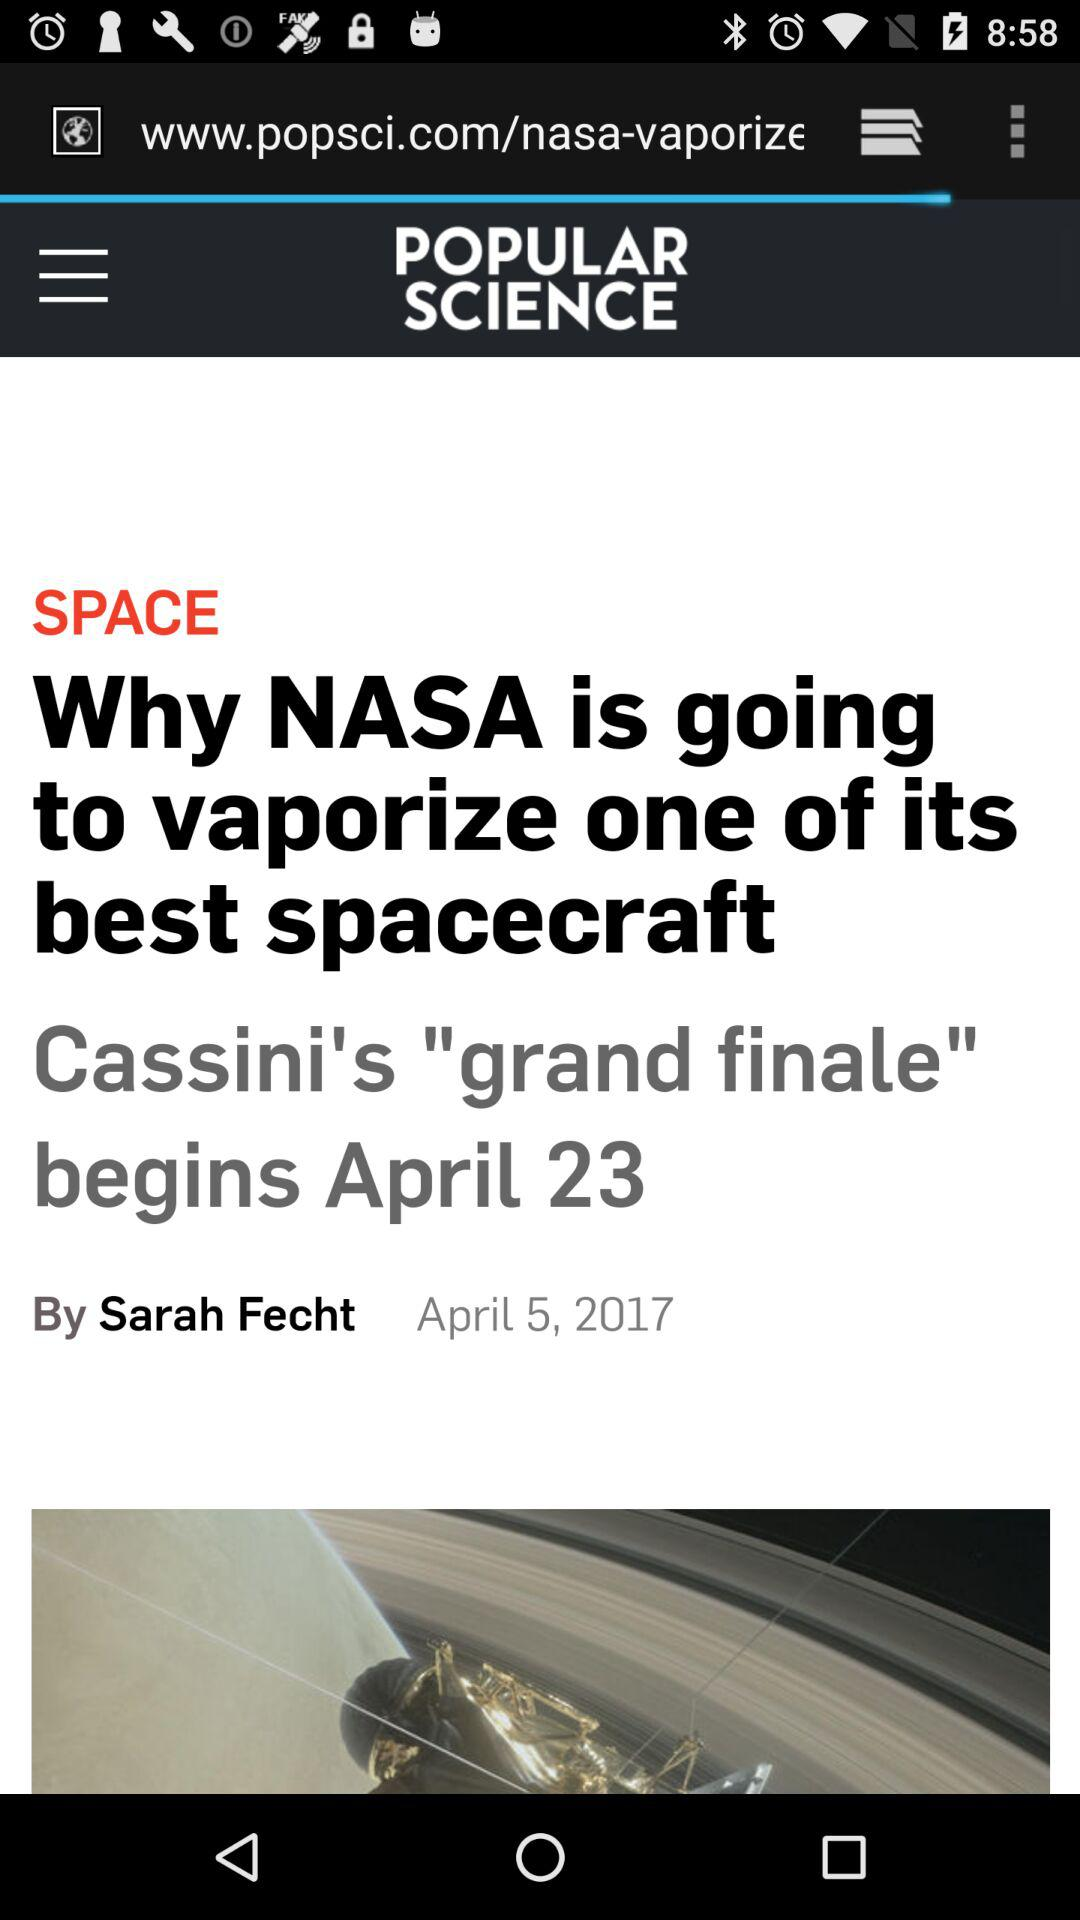On what date does Cassini's grand finale begins? Cassini's grand finale begins on April 23. 